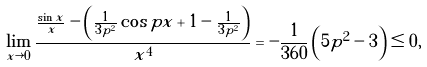<formula> <loc_0><loc_0><loc_500><loc_500>\lim _ { x \rightarrow 0 } \frac { \frac { \sin x } { x } - \left ( \frac { 1 } { 3 p ^ { 2 } } \cos p x + 1 - \frac { 1 } { 3 p ^ { 2 } } \right ) } { x ^ { 4 } } = - \frac { 1 } { 3 6 0 } \left ( 5 p ^ { 2 } - 3 \right ) \leq 0 ,</formula> 